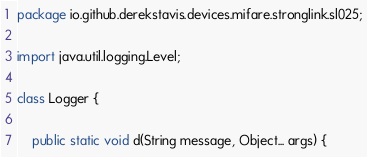<code> <loc_0><loc_0><loc_500><loc_500><_Java_>package io.github.derekstavis.devices.mifare.stronglink.sl025;

import java.util.logging.Level;

class Logger {
	
	public static void d(String message, Object... args) {</code> 